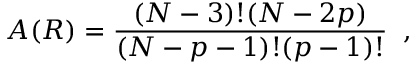Convert formula to latex. <formula><loc_0><loc_0><loc_500><loc_500>A ( R ) = \frac { ( N - 3 ) ! ( N - 2 p ) } { ( N - p - 1 ) ! ( p - 1 ) ! } \, ,</formula> 